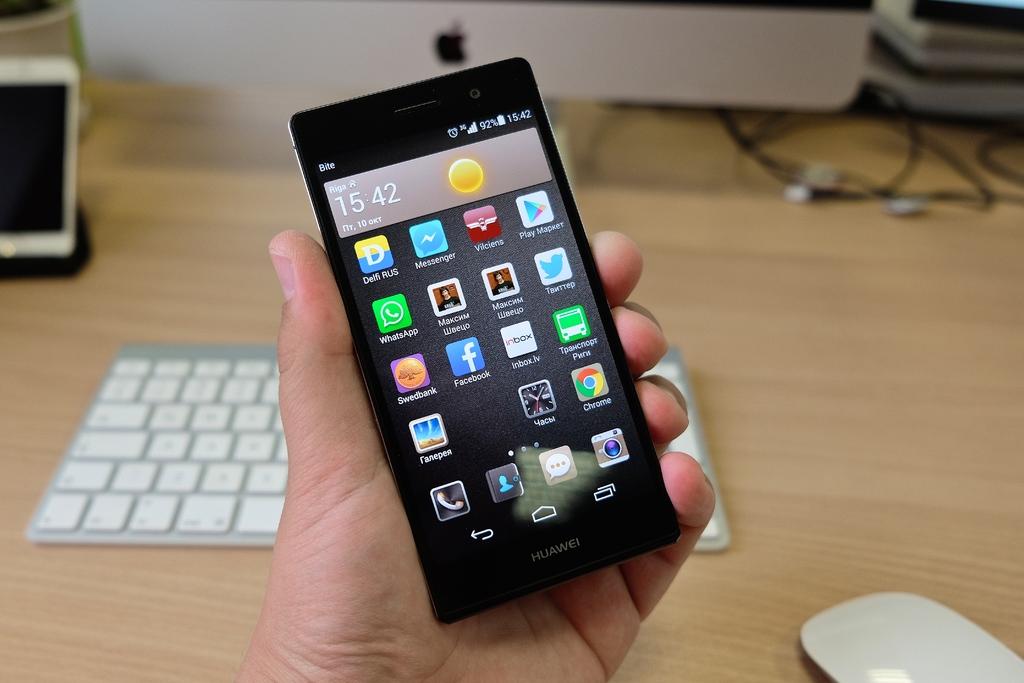What brand of phone is this?
Make the answer very short. Huawei. What time is shown on the phone?
Provide a succinct answer. 15:42. 